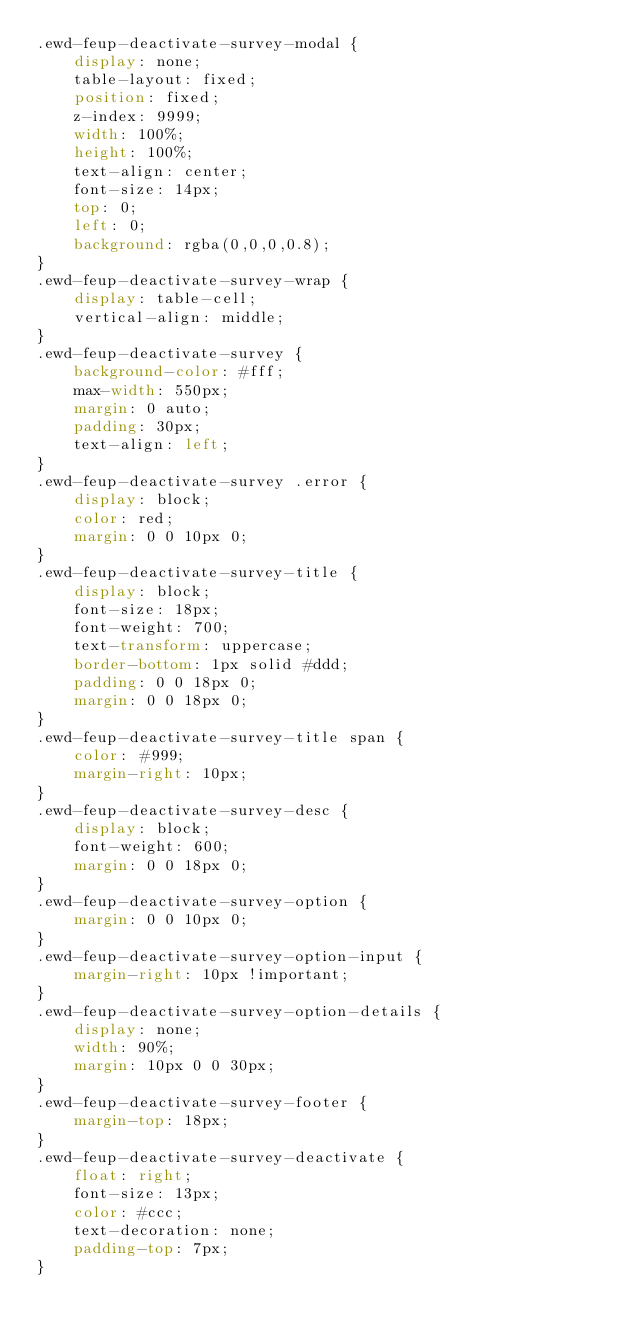Convert code to text. <code><loc_0><loc_0><loc_500><loc_500><_CSS_>.ewd-feup-deactivate-survey-modal {
	display: none;
	table-layout: fixed;
	position: fixed;
	z-index: 9999;
	width: 100%;
	height: 100%;
	text-align: center;
	font-size: 14px;
	top: 0;
	left: 0;
	background: rgba(0,0,0,0.8);
}
.ewd-feup-deactivate-survey-wrap {
	display: table-cell;
	vertical-align: middle;
}
.ewd-feup-deactivate-survey {
	background-color: #fff;
	max-width: 550px;
	margin: 0 auto;
	padding: 30px;
	text-align: left;
}
.ewd-feup-deactivate-survey .error {
	display: block;
	color: red;
	margin: 0 0 10px 0;
}
.ewd-feup-deactivate-survey-title {
	display: block;
	font-size: 18px;
	font-weight: 700;
	text-transform: uppercase;
	border-bottom: 1px solid #ddd;
	padding: 0 0 18px 0;
	margin: 0 0 18px 0;
}
.ewd-feup-deactivate-survey-title span {
	color: #999;
	margin-right: 10px;
}
.ewd-feup-deactivate-survey-desc {
	display: block;
	font-weight: 600;
	margin: 0 0 18px 0;
}
.ewd-feup-deactivate-survey-option {
	margin: 0 0 10px 0;
}
.ewd-feup-deactivate-survey-option-input {
	margin-right: 10px !important;
}
.ewd-feup-deactivate-survey-option-details {
	display: none;
	width: 90%;
	margin: 10px 0 0 30px;
}
.ewd-feup-deactivate-survey-footer {
	margin-top: 18px;
}
.ewd-feup-deactivate-survey-deactivate {
	float: right;
	font-size: 13px;
	color: #ccc;
	text-decoration: none;
	padding-top: 7px;
}</code> 